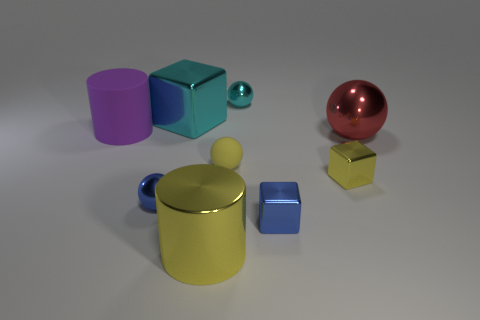How many large cylinders are made of the same material as the small blue block?
Keep it short and to the point. 1. What is the color of the cylinder that is the same material as the large cyan thing?
Your answer should be compact. Yellow. There is a yellow shiny cube; does it have the same size as the shiny thing that is in front of the small blue cube?
Offer a very short reply. No. The yellow thing behind the tiny yellow object that is in front of the matte object that is right of the cyan cube is made of what material?
Provide a short and direct response. Rubber. What number of things are either small brown shiny cylinders or yellow shiny things?
Provide a succinct answer. 2. Is the color of the large cylinder in front of the yellow rubber thing the same as the large thing that is behind the large purple cylinder?
Offer a terse response. No. What is the shape of the red object that is the same size as the cyan block?
Your answer should be very brief. Sphere. How many objects are either large metal objects behind the red ball or tiny objects to the left of the metal cylinder?
Give a very brief answer. 2. Is the number of red shiny spheres less than the number of purple matte spheres?
Make the answer very short. No. There is a sphere that is the same size as the cyan shiny block; what is it made of?
Provide a short and direct response. Metal. 